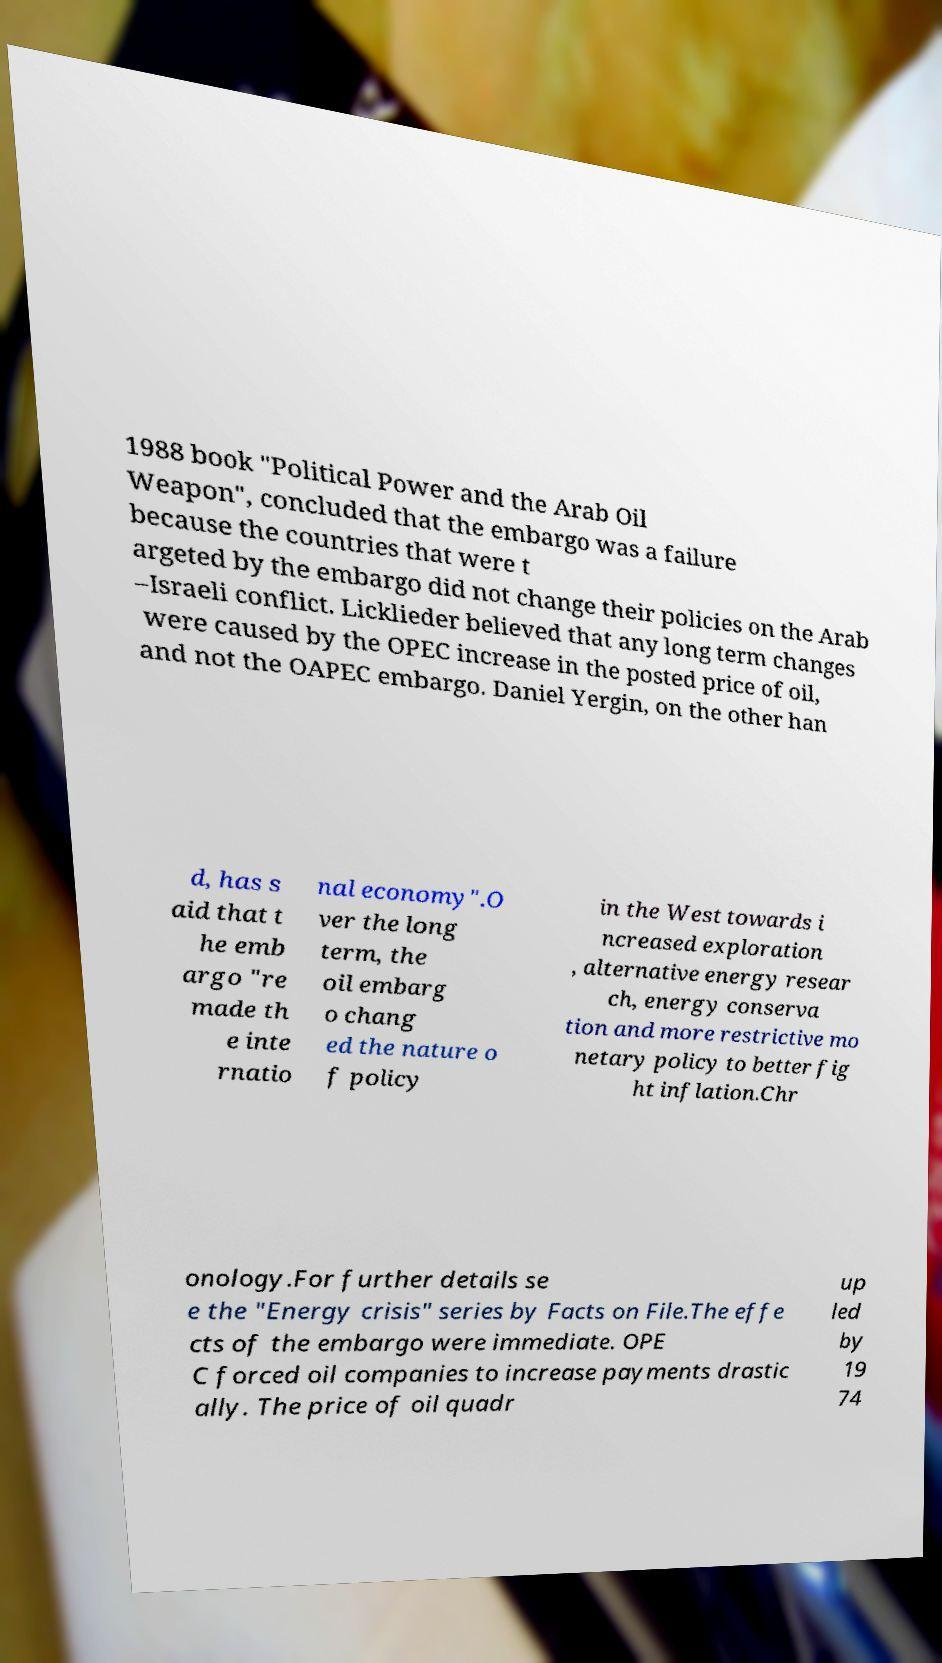There's text embedded in this image that I need extracted. Can you transcribe it verbatim? 1988 book "Political Power and the Arab Oil Weapon", concluded that the embargo was a failure because the countries that were t argeted by the embargo did not change their policies on the Arab –Israeli conflict. Licklieder believed that any long term changes were caused by the OPEC increase in the posted price of oil, and not the OAPEC embargo. Daniel Yergin, on the other han d, has s aid that t he emb argo "re made th e inte rnatio nal economy".O ver the long term, the oil embarg o chang ed the nature o f policy in the West towards i ncreased exploration , alternative energy resear ch, energy conserva tion and more restrictive mo netary policy to better fig ht inflation.Chr onology.For further details se e the "Energy crisis" series by Facts on File.The effe cts of the embargo were immediate. OPE C forced oil companies to increase payments drastic ally. The price of oil quadr up led by 19 74 